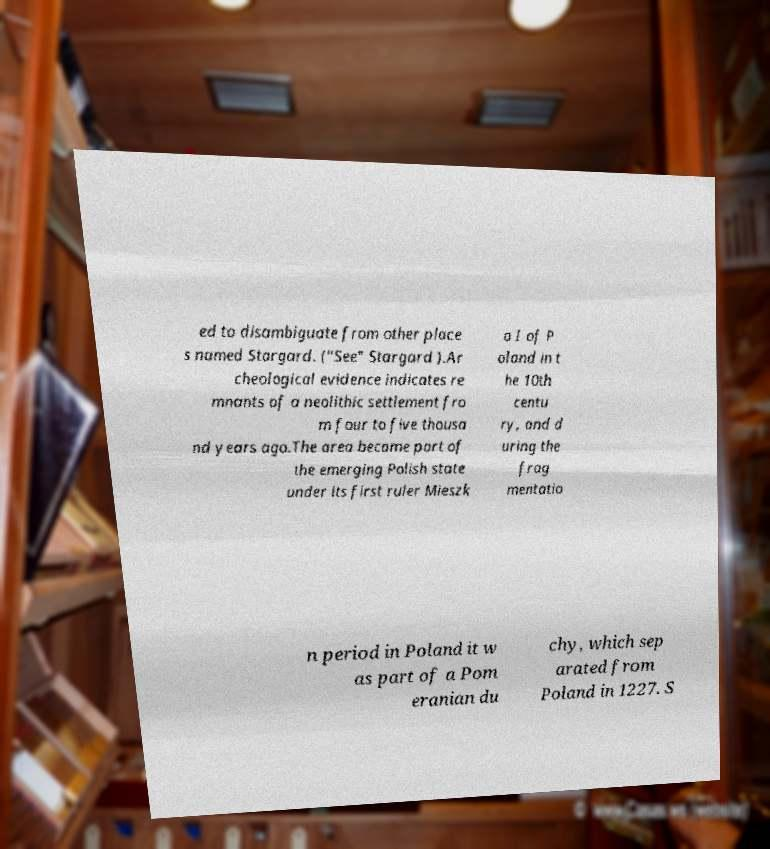Could you extract and type out the text from this image? ed to disambiguate from other place s named Stargard. ("See" Stargard ).Ar cheological evidence indicates re mnants of a neolithic settlement fro m four to five thousa nd years ago.The area became part of the emerging Polish state under its first ruler Mieszk o I of P oland in t he 10th centu ry, and d uring the frag mentatio n period in Poland it w as part of a Pom eranian du chy, which sep arated from Poland in 1227. S 